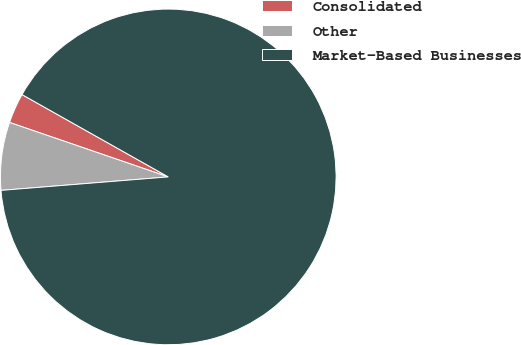<chart> <loc_0><loc_0><loc_500><loc_500><pie_chart><fcel>Consolidated<fcel>Other<fcel>Market-Based Businesses<nl><fcel>2.9%<fcel>6.54%<fcel>90.56%<nl></chart> 